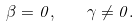<formula> <loc_0><loc_0><loc_500><loc_500>\beta = 0 , \quad \gamma \neq 0 .</formula> 